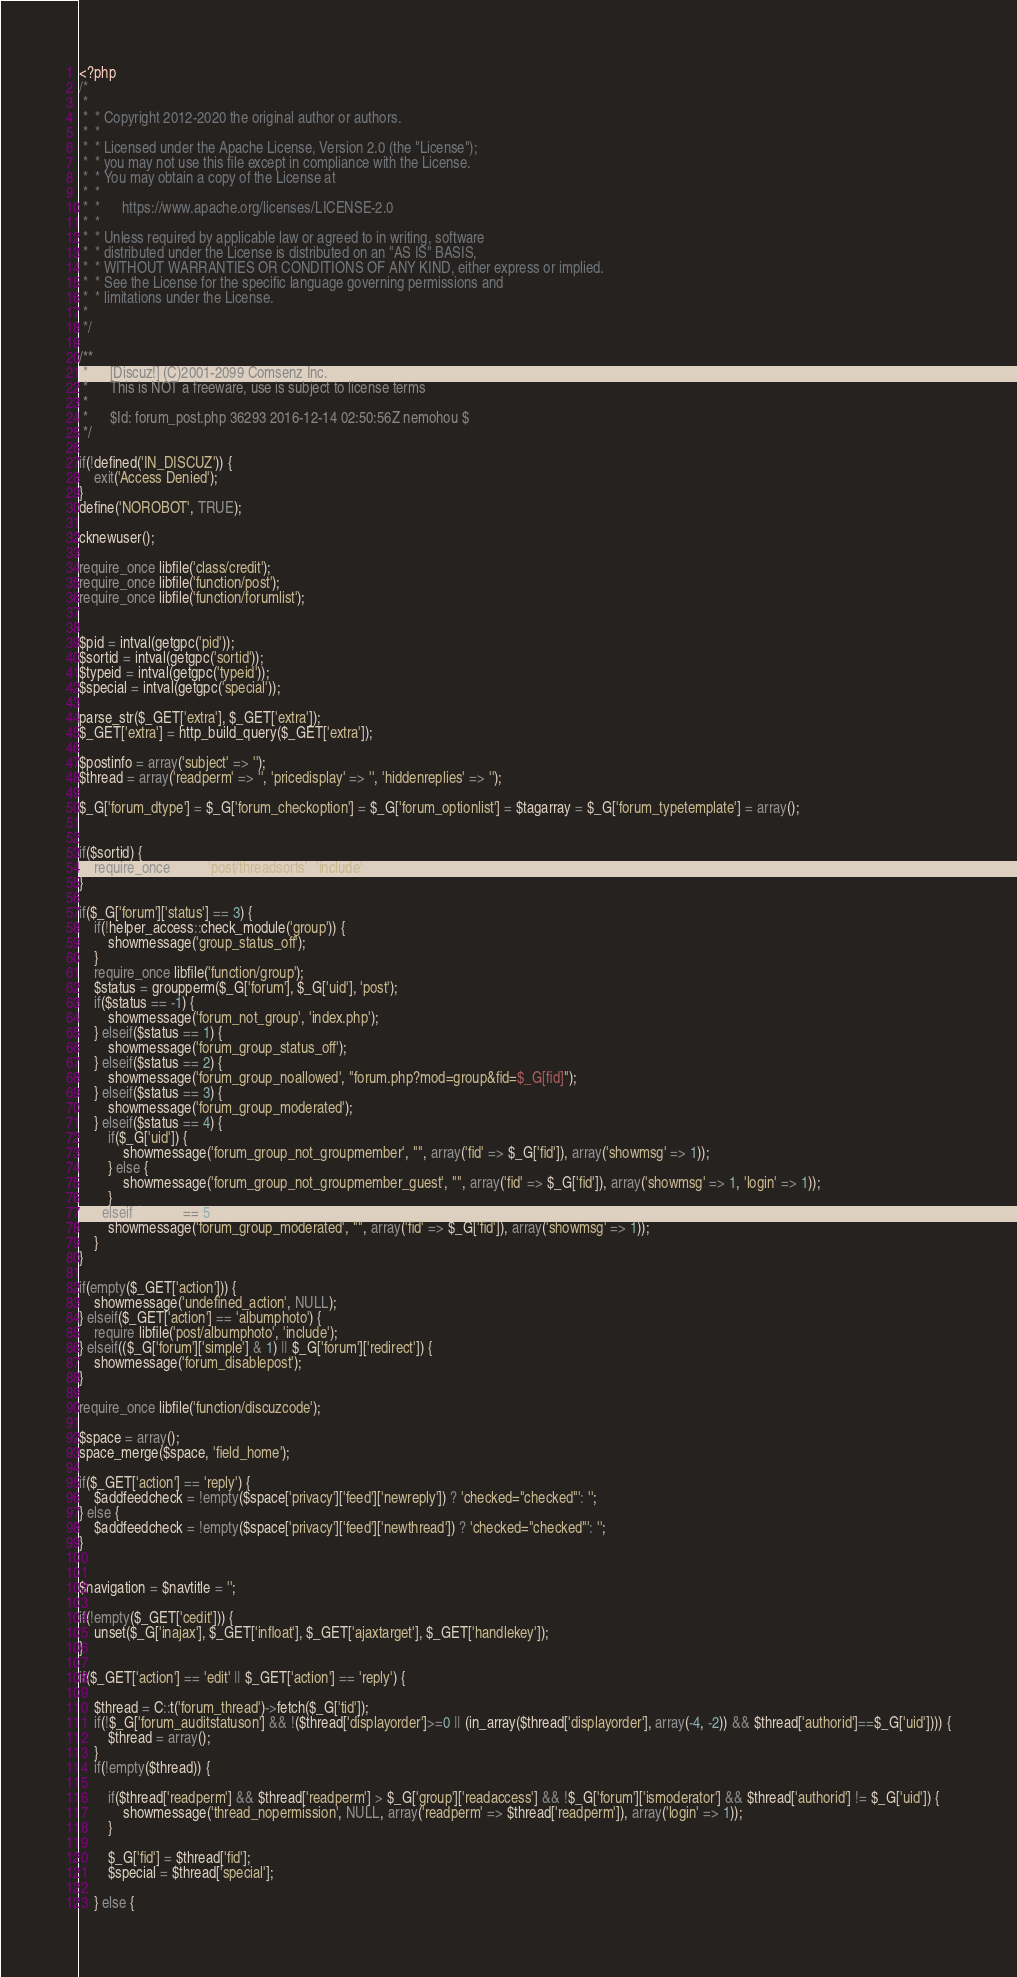<code> <loc_0><loc_0><loc_500><loc_500><_PHP_><?php
/*
 *
 *  * Copyright 2012-2020 the original author or authors.
 *  *
 *  * Licensed under the Apache License, Version 2.0 (the "License");
 *  * you may not use this file except in compliance with the License.
 *  * You may obtain a copy of the License at
 *  *
 *  *      https://www.apache.org/licenses/LICENSE-2.0
 *  *
 *  * Unless required by applicable law or agreed to in writing, software
 *  * distributed under the License is distributed on an "AS IS" BASIS,
 *  * WITHOUT WARRANTIES OR CONDITIONS OF ANY KIND, either express or implied.
 *  * See the License for the specific language governing permissions and
 *  * limitations under the License.
 *
 */

/**
 *      [Discuz!] (C)2001-2099 Comsenz Inc.
 *      This is NOT a freeware, use is subject to license terms
 *
 *      $Id: forum_post.php 36293 2016-12-14 02:50:56Z nemohou $
 */

if(!defined('IN_DISCUZ')) {
	exit('Access Denied');
}
define('NOROBOT', TRUE);

cknewuser();

require_once libfile('class/credit');
require_once libfile('function/post');
require_once libfile('function/forumlist');


$pid = intval(getgpc('pid'));
$sortid = intval(getgpc('sortid'));
$typeid = intval(getgpc('typeid'));
$special = intval(getgpc('special'));

parse_str($_GET['extra'], $_GET['extra']);
$_GET['extra'] = http_build_query($_GET['extra']);

$postinfo = array('subject' => '');
$thread = array('readperm' => '', 'pricedisplay' => '', 'hiddenreplies' => '');

$_G['forum_dtype'] = $_G['forum_checkoption'] = $_G['forum_optionlist'] = $tagarray = $_G['forum_typetemplate'] = array();


if($sortid) {
	require_once libfile('post/threadsorts', 'include');
}

if($_G['forum']['status'] == 3) {
	if(!helper_access::check_module('group')) {
		showmessage('group_status_off');
	}
	require_once libfile('function/group');
	$status = groupperm($_G['forum'], $_G['uid'], 'post');
	if($status == -1) {
		showmessage('forum_not_group', 'index.php');
	} elseif($status == 1) {
		showmessage('forum_group_status_off');
	} elseif($status == 2) {
		showmessage('forum_group_noallowed', "forum.php?mod=group&fid=$_G[fid]");
	} elseif($status == 3) {
		showmessage('forum_group_moderated');
	} elseif($status == 4) {
		if($_G['uid']) {
			showmessage('forum_group_not_groupmember', "", array('fid' => $_G['fid']), array('showmsg' => 1));
		} else {
			showmessage('forum_group_not_groupmember_guest', "", array('fid' => $_G['fid']), array('showmsg' => 1, 'login' => 1));
		}
	} elseif($status == 5) {
		showmessage('forum_group_moderated', "", array('fid' => $_G['fid']), array('showmsg' => 1));
	}
}

if(empty($_GET['action'])) {
	showmessage('undefined_action', NULL);
} elseif($_GET['action'] == 'albumphoto') {
	require libfile('post/albumphoto', 'include');
} elseif(($_G['forum']['simple'] & 1) || $_G['forum']['redirect']) {
	showmessage('forum_disablepost');
}

require_once libfile('function/discuzcode');

$space = array();
space_merge($space, 'field_home');

if($_GET['action'] == 'reply') {
	$addfeedcheck = !empty($space['privacy']['feed']['newreply']) ? 'checked="checked"': '';
} else {
	$addfeedcheck = !empty($space['privacy']['feed']['newthread']) ? 'checked="checked"': '';
}


$navigation = $navtitle = '';

if(!empty($_GET['cedit'])) {
	unset($_G['inajax'], $_GET['infloat'], $_GET['ajaxtarget'], $_GET['handlekey']);
}

if($_GET['action'] == 'edit' || $_GET['action'] == 'reply') {

	$thread = C::t('forum_thread')->fetch($_G['tid']);
	if(!$_G['forum_auditstatuson'] && !($thread['displayorder']>=0 || (in_array($thread['displayorder'], array(-4, -2)) && $thread['authorid']==$_G['uid']))) {
		$thread = array();
	}
	if(!empty($thread)) {

		if($thread['readperm'] && $thread['readperm'] > $_G['group']['readaccess'] && !$_G['forum']['ismoderator'] && $thread['authorid'] != $_G['uid']) {
			showmessage('thread_nopermission', NULL, array('readperm' => $thread['readperm']), array('login' => 1));
		}

		$_G['fid'] = $thread['fid'];
		$special = $thread['special'];

	} else {</code> 